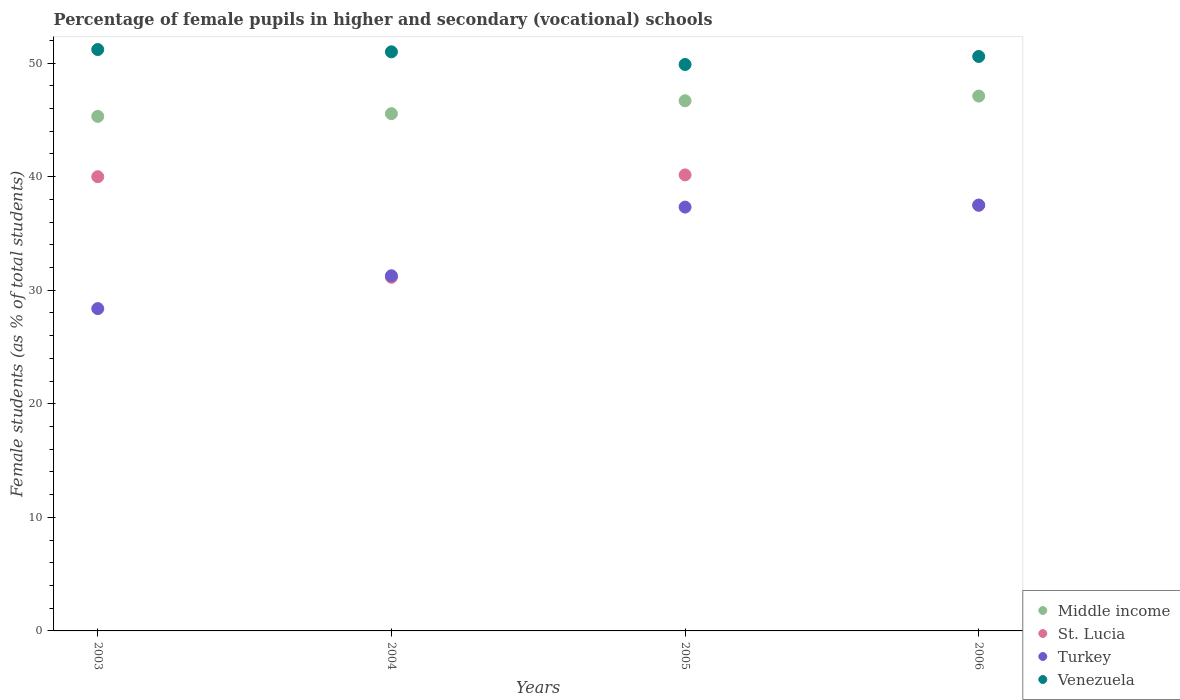Is the number of dotlines equal to the number of legend labels?
Your response must be concise. Yes. What is the percentage of female pupils in higher and secondary schools in St. Lucia in 2004?
Your response must be concise. 31.14. Across all years, what is the maximum percentage of female pupils in higher and secondary schools in St. Lucia?
Offer a terse response. 40.16. Across all years, what is the minimum percentage of female pupils in higher and secondary schools in Middle income?
Your answer should be very brief. 45.31. In which year was the percentage of female pupils in higher and secondary schools in Turkey minimum?
Provide a succinct answer. 2003. What is the total percentage of female pupils in higher and secondary schools in Middle income in the graph?
Your answer should be very brief. 184.65. What is the difference between the percentage of female pupils in higher and secondary schools in Turkey in 2005 and that in 2006?
Offer a terse response. -0.18. What is the difference between the percentage of female pupils in higher and secondary schools in St. Lucia in 2003 and the percentage of female pupils in higher and secondary schools in Middle income in 2005?
Keep it short and to the point. -6.69. What is the average percentage of female pupils in higher and secondary schools in Middle income per year?
Give a very brief answer. 46.16. In the year 2005, what is the difference between the percentage of female pupils in higher and secondary schools in St. Lucia and percentage of female pupils in higher and secondary schools in Middle income?
Your response must be concise. -6.53. What is the ratio of the percentage of female pupils in higher and secondary schools in Turkey in 2003 to that in 2005?
Give a very brief answer. 0.76. Is the difference between the percentage of female pupils in higher and secondary schools in St. Lucia in 2003 and 2004 greater than the difference between the percentage of female pupils in higher and secondary schools in Middle income in 2003 and 2004?
Make the answer very short. Yes. What is the difference between the highest and the second highest percentage of female pupils in higher and secondary schools in Middle income?
Provide a short and direct response. 0.41. What is the difference between the highest and the lowest percentage of female pupils in higher and secondary schools in Turkey?
Provide a short and direct response. 9.12. In how many years, is the percentage of female pupils in higher and secondary schools in Middle income greater than the average percentage of female pupils in higher and secondary schools in Middle income taken over all years?
Provide a short and direct response. 2. Is it the case that in every year, the sum of the percentage of female pupils in higher and secondary schools in Venezuela and percentage of female pupils in higher and secondary schools in Turkey  is greater than the percentage of female pupils in higher and secondary schools in Middle income?
Ensure brevity in your answer.  Yes. What is the difference between two consecutive major ticks on the Y-axis?
Give a very brief answer. 10. Are the values on the major ticks of Y-axis written in scientific E-notation?
Ensure brevity in your answer.  No. Where does the legend appear in the graph?
Provide a short and direct response. Bottom right. How many legend labels are there?
Keep it short and to the point. 4. How are the legend labels stacked?
Ensure brevity in your answer.  Vertical. What is the title of the graph?
Offer a very short reply. Percentage of female pupils in higher and secondary (vocational) schools. Does "Macedonia" appear as one of the legend labels in the graph?
Provide a succinct answer. No. What is the label or title of the Y-axis?
Your answer should be compact. Female students (as % of total students). What is the Female students (as % of total students) in Middle income in 2003?
Give a very brief answer. 45.31. What is the Female students (as % of total students) of Turkey in 2003?
Offer a very short reply. 28.38. What is the Female students (as % of total students) of Venezuela in 2003?
Offer a very short reply. 51.2. What is the Female students (as % of total students) of Middle income in 2004?
Your answer should be compact. 45.55. What is the Female students (as % of total students) of St. Lucia in 2004?
Ensure brevity in your answer.  31.14. What is the Female students (as % of total students) in Turkey in 2004?
Ensure brevity in your answer.  31.28. What is the Female students (as % of total students) of Venezuela in 2004?
Make the answer very short. 51. What is the Female students (as % of total students) in Middle income in 2005?
Your answer should be very brief. 46.69. What is the Female students (as % of total students) of St. Lucia in 2005?
Make the answer very short. 40.16. What is the Female students (as % of total students) of Turkey in 2005?
Keep it short and to the point. 37.32. What is the Female students (as % of total students) in Venezuela in 2005?
Give a very brief answer. 49.88. What is the Female students (as % of total students) in Middle income in 2006?
Provide a succinct answer. 47.1. What is the Female students (as % of total students) of St. Lucia in 2006?
Your answer should be compact. 37.48. What is the Female students (as % of total students) in Turkey in 2006?
Give a very brief answer. 37.5. What is the Female students (as % of total students) in Venezuela in 2006?
Give a very brief answer. 50.59. Across all years, what is the maximum Female students (as % of total students) in Middle income?
Offer a terse response. 47.1. Across all years, what is the maximum Female students (as % of total students) in St. Lucia?
Ensure brevity in your answer.  40.16. Across all years, what is the maximum Female students (as % of total students) of Turkey?
Give a very brief answer. 37.5. Across all years, what is the maximum Female students (as % of total students) of Venezuela?
Your answer should be very brief. 51.2. Across all years, what is the minimum Female students (as % of total students) in Middle income?
Your response must be concise. 45.31. Across all years, what is the minimum Female students (as % of total students) in St. Lucia?
Offer a very short reply. 31.14. Across all years, what is the minimum Female students (as % of total students) of Turkey?
Make the answer very short. 28.38. Across all years, what is the minimum Female students (as % of total students) of Venezuela?
Your response must be concise. 49.88. What is the total Female students (as % of total students) in Middle income in the graph?
Provide a succinct answer. 184.65. What is the total Female students (as % of total students) of St. Lucia in the graph?
Make the answer very short. 148.78. What is the total Female students (as % of total students) in Turkey in the graph?
Ensure brevity in your answer.  134.48. What is the total Female students (as % of total students) of Venezuela in the graph?
Offer a terse response. 202.66. What is the difference between the Female students (as % of total students) in Middle income in 2003 and that in 2004?
Provide a succinct answer. -0.24. What is the difference between the Female students (as % of total students) in St. Lucia in 2003 and that in 2004?
Offer a very short reply. 8.86. What is the difference between the Female students (as % of total students) in Turkey in 2003 and that in 2004?
Ensure brevity in your answer.  -2.89. What is the difference between the Female students (as % of total students) in Venezuela in 2003 and that in 2004?
Keep it short and to the point. 0.2. What is the difference between the Female students (as % of total students) of Middle income in 2003 and that in 2005?
Your answer should be very brief. -1.38. What is the difference between the Female students (as % of total students) in St. Lucia in 2003 and that in 2005?
Provide a succinct answer. -0.16. What is the difference between the Female students (as % of total students) of Turkey in 2003 and that in 2005?
Your answer should be very brief. -8.94. What is the difference between the Female students (as % of total students) of Venezuela in 2003 and that in 2005?
Your answer should be very brief. 1.32. What is the difference between the Female students (as % of total students) of Middle income in 2003 and that in 2006?
Keep it short and to the point. -1.79. What is the difference between the Female students (as % of total students) of St. Lucia in 2003 and that in 2006?
Your response must be concise. 2.52. What is the difference between the Female students (as % of total students) in Turkey in 2003 and that in 2006?
Offer a very short reply. -9.12. What is the difference between the Female students (as % of total students) of Venezuela in 2003 and that in 2006?
Keep it short and to the point. 0.61. What is the difference between the Female students (as % of total students) in Middle income in 2004 and that in 2005?
Your response must be concise. -1.14. What is the difference between the Female students (as % of total students) in St. Lucia in 2004 and that in 2005?
Offer a terse response. -9.02. What is the difference between the Female students (as % of total students) of Turkey in 2004 and that in 2005?
Your response must be concise. -6.05. What is the difference between the Female students (as % of total students) in Venezuela in 2004 and that in 2005?
Your answer should be compact. 1.12. What is the difference between the Female students (as % of total students) of Middle income in 2004 and that in 2006?
Ensure brevity in your answer.  -1.55. What is the difference between the Female students (as % of total students) in St. Lucia in 2004 and that in 2006?
Your answer should be very brief. -6.34. What is the difference between the Female students (as % of total students) in Turkey in 2004 and that in 2006?
Your answer should be compact. -6.22. What is the difference between the Female students (as % of total students) of Venezuela in 2004 and that in 2006?
Make the answer very short. 0.41. What is the difference between the Female students (as % of total students) in Middle income in 2005 and that in 2006?
Offer a very short reply. -0.41. What is the difference between the Female students (as % of total students) in St. Lucia in 2005 and that in 2006?
Ensure brevity in your answer.  2.68. What is the difference between the Female students (as % of total students) in Turkey in 2005 and that in 2006?
Keep it short and to the point. -0.18. What is the difference between the Female students (as % of total students) of Venezuela in 2005 and that in 2006?
Your answer should be compact. -0.71. What is the difference between the Female students (as % of total students) in Middle income in 2003 and the Female students (as % of total students) in St. Lucia in 2004?
Provide a short and direct response. 14.17. What is the difference between the Female students (as % of total students) of Middle income in 2003 and the Female students (as % of total students) of Turkey in 2004?
Offer a terse response. 14.03. What is the difference between the Female students (as % of total students) in Middle income in 2003 and the Female students (as % of total students) in Venezuela in 2004?
Offer a terse response. -5.69. What is the difference between the Female students (as % of total students) of St. Lucia in 2003 and the Female students (as % of total students) of Turkey in 2004?
Keep it short and to the point. 8.72. What is the difference between the Female students (as % of total students) of St. Lucia in 2003 and the Female students (as % of total students) of Venezuela in 2004?
Offer a terse response. -11. What is the difference between the Female students (as % of total students) in Turkey in 2003 and the Female students (as % of total students) in Venezuela in 2004?
Your response must be concise. -22.61. What is the difference between the Female students (as % of total students) of Middle income in 2003 and the Female students (as % of total students) of St. Lucia in 2005?
Your response must be concise. 5.15. What is the difference between the Female students (as % of total students) of Middle income in 2003 and the Female students (as % of total students) of Turkey in 2005?
Your answer should be very brief. 7.99. What is the difference between the Female students (as % of total students) in Middle income in 2003 and the Female students (as % of total students) in Venezuela in 2005?
Give a very brief answer. -4.57. What is the difference between the Female students (as % of total students) in St. Lucia in 2003 and the Female students (as % of total students) in Turkey in 2005?
Keep it short and to the point. 2.68. What is the difference between the Female students (as % of total students) of St. Lucia in 2003 and the Female students (as % of total students) of Venezuela in 2005?
Provide a short and direct response. -9.88. What is the difference between the Female students (as % of total students) in Turkey in 2003 and the Female students (as % of total students) in Venezuela in 2005?
Provide a short and direct response. -21.5. What is the difference between the Female students (as % of total students) of Middle income in 2003 and the Female students (as % of total students) of St. Lucia in 2006?
Your answer should be very brief. 7.83. What is the difference between the Female students (as % of total students) of Middle income in 2003 and the Female students (as % of total students) of Turkey in 2006?
Offer a terse response. 7.81. What is the difference between the Female students (as % of total students) of Middle income in 2003 and the Female students (as % of total students) of Venezuela in 2006?
Ensure brevity in your answer.  -5.28. What is the difference between the Female students (as % of total students) in St. Lucia in 2003 and the Female students (as % of total students) in Turkey in 2006?
Your response must be concise. 2.5. What is the difference between the Female students (as % of total students) of St. Lucia in 2003 and the Female students (as % of total students) of Venezuela in 2006?
Your answer should be compact. -10.59. What is the difference between the Female students (as % of total students) in Turkey in 2003 and the Female students (as % of total students) in Venezuela in 2006?
Make the answer very short. -22.2. What is the difference between the Female students (as % of total students) of Middle income in 2004 and the Female students (as % of total students) of St. Lucia in 2005?
Your answer should be compact. 5.39. What is the difference between the Female students (as % of total students) in Middle income in 2004 and the Female students (as % of total students) in Turkey in 2005?
Provide a succinct answer. 8.23. What is the difference between the Female students (as % of total students) of Middle income in 2004 and the Female students (as % of total students) of Venezuela in 2005?
Provide a succinct answer. -4.33. What is the difference between the Female students (as % of total students) in St. Lucia in 2004 and the Female students (as % of total students) in Turkey in 2005?
Offer a very short reply. -6.18. What is the difference between the Female students (as % of total students) in St. Lucia in 2004 and the Female students (as % of total students) in Venezuela in 2005?
Your answer should be very brief. -18.74. What is the difference between the Female students (as % of total students) of Turkey in 2004 and the Female students (as % of total students) of Venezuela in 2005?
Your response must be concise. -18.6. What is the difference between the Female students (as % of total students) of Middle income in 2004 and the Female students (as % of total students) of St. Lucia in 2006?
Your answer should be very brief. 8.07. What is the difference between the Female students (as % of total students) of Middle income in 2004 and the Female students (as % of total students) of Turkey in 2006?
Your answer should be very brief. 8.05. What is the difference between the Female students (as % of total students) in Middle income in 2004 and the Female students (as % of total students) in Venezuela in 2006?
Make the answer very short. -5.04. What is the difference between the Female students (as % of total students) in St. Lucia in 2004 and the Female students (as % of total students) in Turkey in 2006?
Give a very brief answer. -6.36. What is the difference between the Female students (as % of total students) of St. Lucia in 2004 and the Female students (as % of total students) of Venezuela in 2006?
Make the answer very short. -19.44. What is the difference between the Female students (as % of total students) of Turkey in 2004 and the Female students (as % of total students) of Venezuela in 2006?
Your answer should be compact. -19.31. What is the difference between the Female students (as % of total students) in Middle income in 2005 and the Female students (as % of total students) in St. Lucia in 2006?
Your answer should be compact. 9.21. What is the difference between the Female students (as % of total students) in Middle income in 2005 and the Female students (as % of total students) in Turkey in 2006?
Keep it short and to the point. 9.19. What is the difference between the Female students (as % of total students) of Middle income in 2005 and the Female students (as % of total students) of Venezuela in 2006?
Make the answer very short. -3.9. What is the difference between the Female students (as % of total students) in St. Lucia in 2005 and the Female students (as % of total students) in Turkey in 2006?
Your answer should be compact. 2.66. What is the difference between the Female students (as % of total students) of St. Lucia in 2005 and the Female students (as % of total students) of Venezuela in 2006?
Offer a terse response. -10.43. What is the difference between the Female students (as % of total students) in Turkey in 2005 and the Female students (as % of total students) in Venezuela in 2006?
Your answer should be compact. -13.26. What is the average Female students (as % of total students) of Middle income per year?
Provide a succinct answer. 46.16. What is the average Female students (as % of total students) in St. Lucia per year?
Provide a succinct answer. 37.2. What is the average Female students (as % of total students) in Turkey per year?
Your response must be concise. 33.62. What is the average Female students (as % of total students) of Venezuela per year?
Provide a short and direct response. 50.67. In the year 2003, what is the difference between the Female students (as % of total students) of Middle income and Female students (as % of total students) of St. Lucia?
Your answer should be very brief. 5.31. In the year 2003, what is the difference between the Female students (as % of total students) in Middle income and Female students (as % of total students) in Turkey?
Your response must be concise. 16.93. In the year 2003, what is the difference between the Female students (as % of total students) in Middle income and Female students (as % of total students) in Venezuela?
Provide a succinct answer. -5.89. In the year 2003, what is the difference between the Female students (as % of total students) in St. Lucia and Female students (as % of total students) in Turkey?
Your answer should be compact. 11.62. In the year 2003, what is the difference between the Female students (as % of total students) of St. Lucia and Female students (as % of total students) of Venezuela?
Your answer should be compact. -11.2. In the year 2003, what is the difference between the Female students (as % of total students) in Turkey and Female students (as % of total students) in Venezuela?
Keep it short and to the point. -22.81. In the year 2004, what is the difference between the Female students (as % of total students) of Middle income and Female students (as % of total students) of St. Lucia?
Your answer should be very brief. 14.41. In the year 2004, what is the difference between the Female students (as % of total students) of Middle income and Female students (as % of total students) of Turkey?
Ensure brevity in your answer.  14.28. In the year 2004, what is the difference between the Female students (as % of total students) of Middle income and Female students (as % of total students) of Venezuela?
Keep it short and to the point. -5.44. In the year 2004, what is the difference between the Female students (as % of total students) of St. Lucia and Female students (as % of total students) of Turkey?
Provide a short and direct response. -0.13. In the year 2004, what is the difference between the Female students (as % of total students) in St. Lucia and Female students (as % of total students) in Venezuela?
Provide a succinct answer. -19.85. In the year 2004, what is the difference between the Female students (as % of total students) in Turkey and Female students (as % of total students) in Venezuela?
Your answer should be compact. -19.72. In the year 2005, what is the difference between the Female students (as % of total students) of Middle income and Female students (as % of total students) of St. Lucia?
Make the answer very short. 6.53. In the year 2005, what is the difference between the Female students (as % of total students) of Middle income and Female students (as % of total students) of Turkey?
Give a very brief answer. 9.37. In the year 2005, what is the difference between the Female students (as % of total students) of Middle income and Female students (as % of total students) of Venezuela?
Offer a terse response. -3.19. In the year 2005, what is the difference between the Female students (as % of total students) in St. Lucia and Female students (as % of total students) in Turkey?
Provide a short and direct response. 2.84. In the year 2005, what is the difference between the Female students (as % of total students) of St. Lucia and Female students (as % of total students) of Venezuela?
Offer a terse response. -9.72. In the year 2005, what is the difference between the Female students (as % of total students) of Turkey and Female students (as % of total students) of Venezuela?
Offer a terse response. -12.56. In the year 2006, what is the difference between the Female students (as % of total students) in Middle income and Female students (as % of total students) in St. Lucia?
Keep it short and to the point. 9.62. In the year 2006, what is the difference between the Female students (as % of total students) of Middle income and Female students (as % of total students) of Turkey?
Your response must be concise. 9.6. In the year 2006, what is the difference between the Female students (as % of total students) of Middle income and Female students (as % of total students) of Venezuela?
Make the answer very short. -3.49. In the year 2006, what is the difference between the Female students (as % of total students) of St. Lucia and Female students (as % of total students) of Turkey?
Offer a very short reply. -0.02. In the year 2006, what is the difference between the Female students (as % of total students) in St. Lucia and Female students (as % of total students) in Venezuela?
Ensure brevity in your answer.  -13.11. In the year 2006, what is the difference between the Female students (as % of total students) in Turkey and Female students (as % of total students) in Venezuela?
Provide a succinct answer. -13.09. What is the ratio of the Female students (as % of total students) in Middle income in 2003 to that in 2004?
Provide a succinct answer. 0.99. What is the ratio of the Female students (as % of total students) in St. Lucia in 2003 to that in 2004?
Your response must be concise. 1.28. What is the ratio of the Female students (as % of total students) of Turkey in 2003 to that in 2004?
Ensure brevity in your answer.  0.91. What is the ratio of the Female students (as % of total students) of Venezuela in 2003 to that in 2004?
Offer a very short reply. 1. What is the ratio of the Female students (as % of total students) of Middle income in 2003 to that in 2005?
Give a very brief answer. 0.97. What is the ratio of the Female students (as % of total students) in Turkey in 2003 to that in 2005?
Make the answer very short. 0.76. What is the ratio of the Female students (as % of total students) in Venezuela in 2003 to that in 2005?
Ensure brevity in your answer.  1.03. What is the ratio of the Female students (as % of total students) of St. Lucia in 2003 to that in 2006?
Offer a terse response. 1.07. What is the ratio of the Female students (as % of total students) in Turkey in 2003 to that in 2006?
Offer a very short reply. 0.76. What is the ratio of the Female students (as % of total students) in Venezuela in 2003 to that in 2006?
Your response must be concise. 1.01. What is the ratio of the Female students (as % of total students) in Middle income in 2004 to that in 2005?
Provide a succinct answer. 0.98. What is the ratio of the Female students (as % of total students) in St. Lucia in 2004 to that in 2005?
Your answer should be compact. 0.78. What is the ratio of the Female students (as % of total students) of Turkey in 2004 to that in 2005?
Your answer should be very brief. 0.84. What is the ratio of the Female students (as % of total students) of Venezuela in 2004 to that in 2005?
Provide a short and direct response. 1.02. What is the ratio of the Female students (as % of total students) of Middle income in 2004 to that in 2006?
Provide a succinct answer. 0.97. What is the ratio of the Female students (as % of total students) of St. Lucia in 2004 to that in 2006?
Your response must be concise. 0.83. What is the ratio of the Female students (as % of total students) of Turkey in 2004 to that in 2006?
Offer a terse response. 0.83. What is the ratio of the Female students (as % of total students) of St. Lucia in 2005 to that in 2006?
Give a very brief answer. 1.07. What is the ratio of the Female students (as % of total students) of Venezuela in 2005 to that in 2006?
Your answer should be compact. 0.99. What is the difference between the highest and the second highest Female students (as % of total students) of Middle income?
Your answer should be very brief. 0.41. What is the difference between the highest and the second highest Female students (as % of total students) of St. Lucia?
Keep it short and to the point. 0.16. What is the difference between the highest and the second highest Female students (as % of total students) of Turkey?
Your answer should be compact. 0.18. What is the difference between the highest and the second highest Female students (as % of total students) in Venezuela?
Provide a short and direct response. 0.2. What is the difference between the highest and the lowest Female students (as % of total students) of Middle income?
Your answer should be very brief. 1.79. What is the difference between the highest and the lowest Female students (as % of total students) in St. Lucia?
Give a very brief answer. 9.02. What is the difference between the highest and the lowest Female students (as % of total students) of Turkey?
Your answer should be compact. 9.12. What is the difference between the highest and the lowest Female students (as % of total students) of Venezuela?
Give a very brief answer. 1.32. 